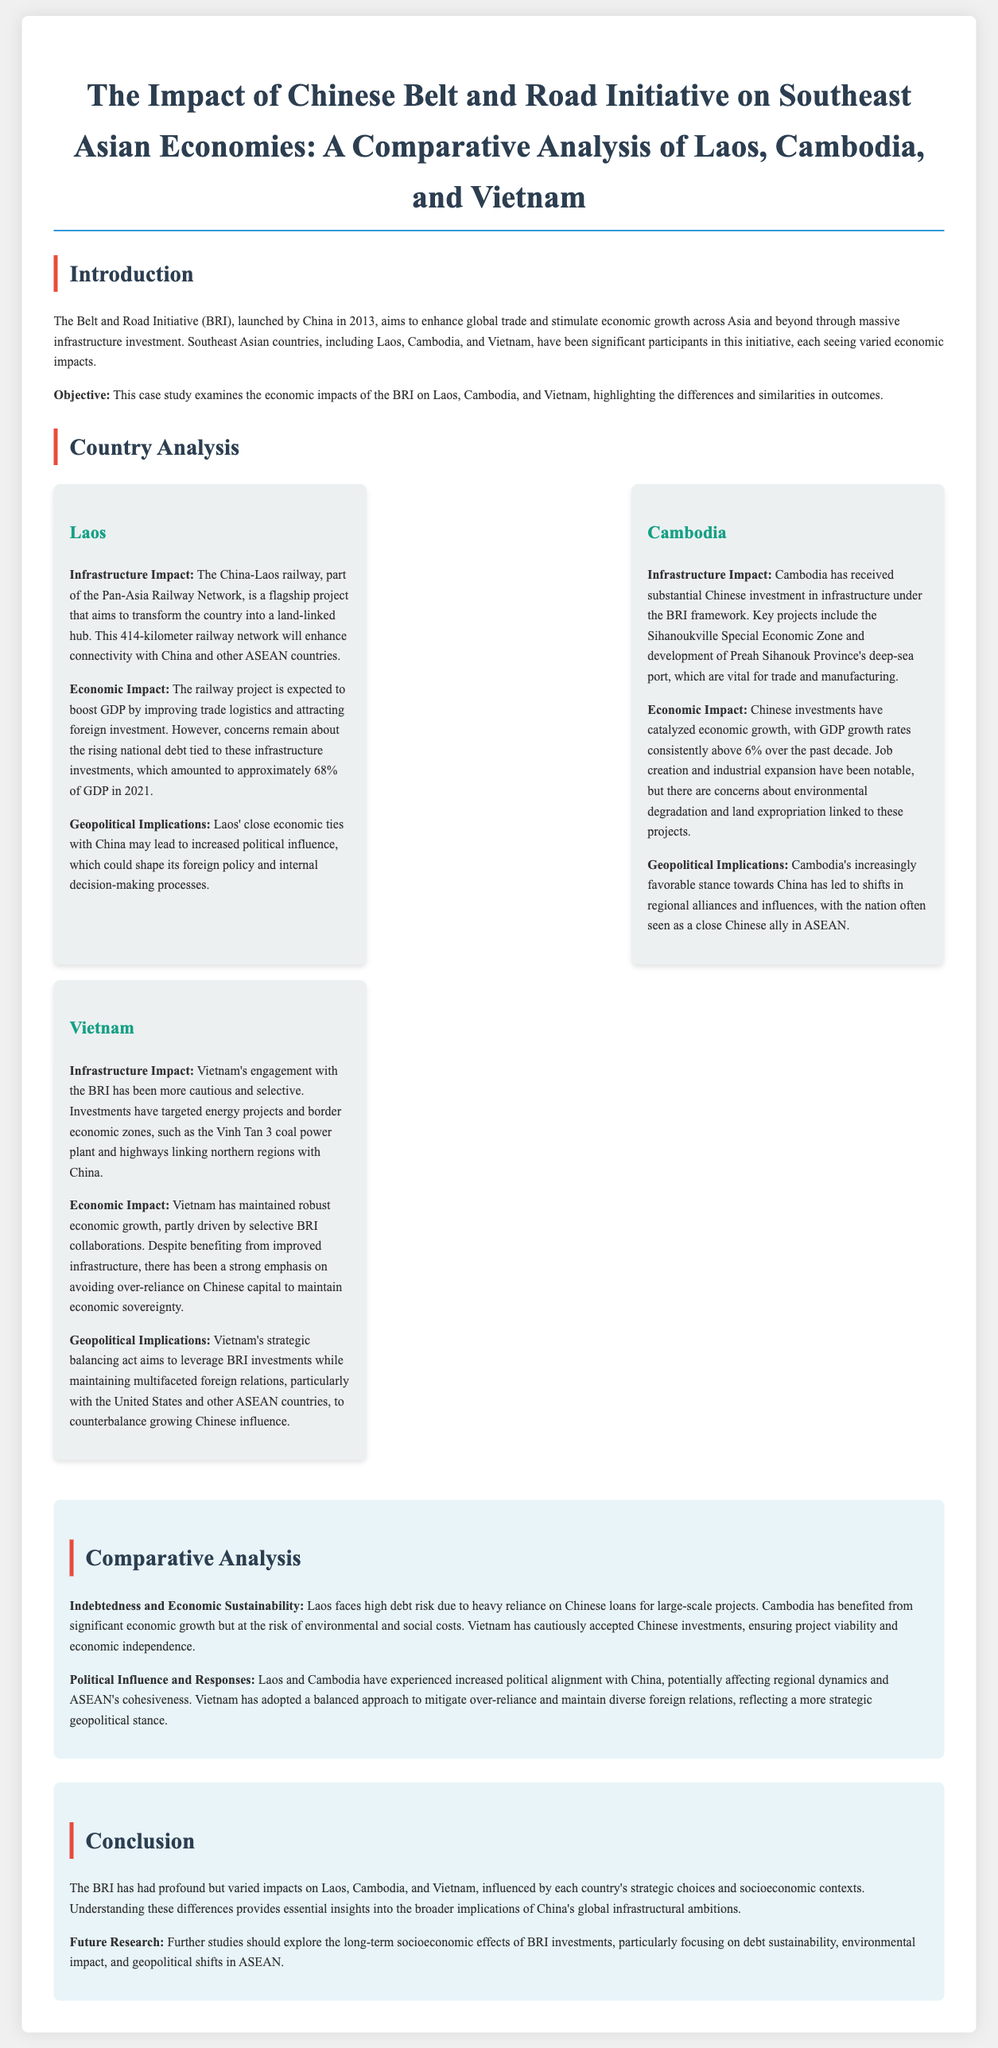What is the objective of the case study? The objective is to examine the economic impacts of the BRI on Laos, Cambodia, and Vietnam, highlighting the differences and similarities in outcomes.
Answer: Examine economic impacts What infrastructure project is a flagship for Laos under the BRI? The flagship project for Laos is the China-Laos railway, which is part of the Pan-Asia Railway Network.
Answer: China-Laos railway What was the GDP increase expectation for Laos due to the railway project? The railway project is expected to boost GDP by improving trade logistics and attracting foreign investment.
Answer: Boost GDP What percentage of GDP was Laos' national debt in 2021? Laos' national debt amounted to approximately 68% of GDP in 2021.
Answer: 68% Which country has maintained GDP growth rates consistently above 6% over the past decade? Cambodia has experienced GDP growth rates consistently above 6% over the past decade.
Answer: Cambodia What is one key concern related to Chinese investments in Cambodia? A key concern is about environmental degradation and land expropriation linked to these projects.
Answer: Environmental degradation How has Vietnam approached Chinese investments under the BRI? Vietnam has engaged with the BRI cautiously and selectively, targeting specific projects.
Answer: Cautiously What are the geopolitical implications for Cambodia as a result of BRI investments? Cambodia's increasingly favorable stance towards China has led to shifts in regional alliances and influences.
Answer: Shifts in regional alliances What does the conclusion suggest for future research? Future research should explore the long-term socioeconomic effects of BRI investments, focusing on debt sustainability, environmental impact, and geopolitical shifts in ASEAN.
Answer: Long-term socioeconomic effects What is a significant risk for Laos according to the comparative analysis? Laos faces high debt risk due to heavy reliance on Chinese loans for large-scale projects.
Answer: High debt risk 